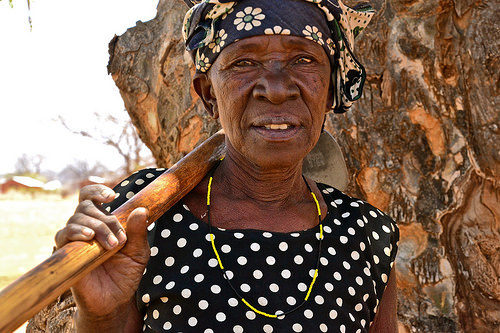<image>
Is the stick in the rock? No. The stick is not contained within the rock. These objects have a different spatial relationship. 